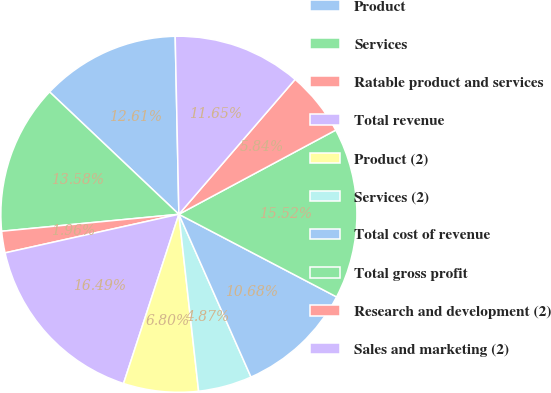Convert chart to OTSL. <chart><loc_0><loc_0><loc_500><loc_500><pie_chart><fcel>Product<fcel>Services<fcel>Ratable product and services<fcel>Total revenue<fcel>Product (2)<fcel>Services (2)<fcel>Total cost of revenue<fcel>Total gross profit<fcel>Research and development (2)<fcel>Sales and marketing (2)<nl><fcel>12.61%<fcel>13.58%<fcel>1.96%<fcel>16.49%<fcel>6.8%<fcel>4.87%<fcel>10.68%<fcel>15.52%<fcel>5.84%<fcel>11.65%<nl></chart> 